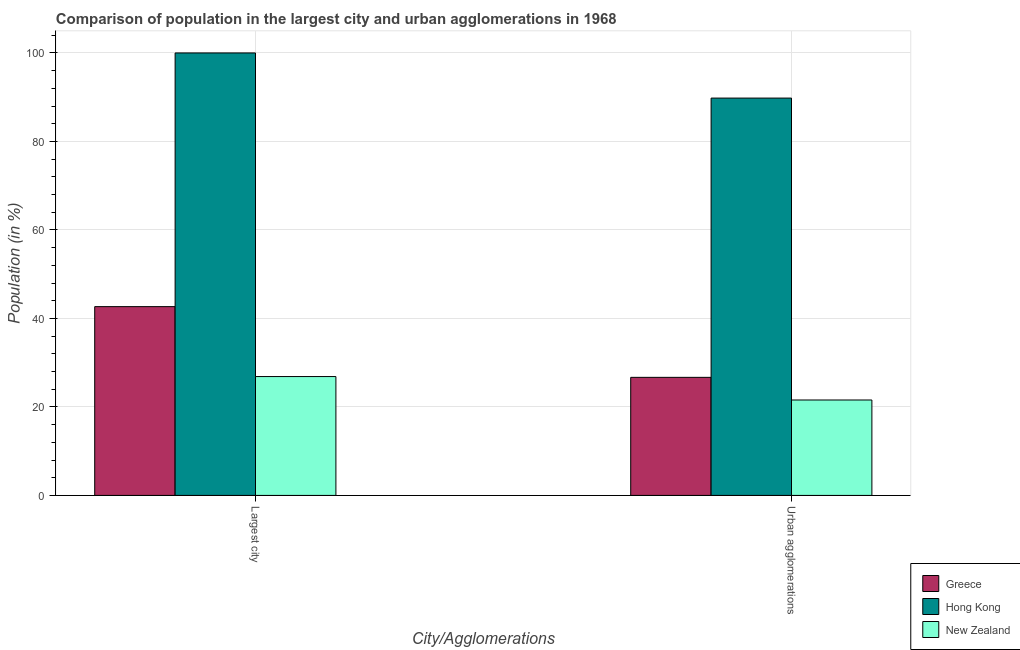How many different coloured bars are there?
Offer a very short reply. 3. How many groups of bars are there?
Your answer should be compact. 2. Are the number of bars on each tick of the X-axis equal?
Give a very brief answer. Yes. What is the label of the 1st group of bars from the left?
Make the answer very short. Largest city. What is the population in urban agglomerations in New Zealand?
Provide a short and direct response. 21.57. Across all countries, what is the minimum population in the largest city?
Your answer should be compact. 26.86. In which country was the population in urban agglomerations maximum?
Ensure brevity in your answer.  Hong Kong. In which country was the population in the largest city minimum?
Your answer should be compact. New Zealand. What is the total population in urban agglomerations in the graph?
Your response must be concise. 138.05. What is the difference between the population in urban agglomerations in Greece and that in Hong Kong?
Your answer should be compact. -63.11. What is the difference between the population in the largest city in New Zealand and the population in urban agglomerations in Greece?
Make the answer very short. 0.18. What is the average population in the largest city per country?
Provide a succinct answer. 56.51. What is the difference between the population in urban agglomerations and population in the largest city in New Zealand?
Ensure brevity in your answer.  -5.3. What is the ratio of the population in the largest city in Hong Kong to that in New Zealand?
Offer a terse response. 3.72. What does the 3rd bar from the right in Largest city represents?
Provide a short and direct response. Greece. How many bars are there?
Give a very brief answer. 6. Are all the bars in the graph horizontal?
Your response must be concise. No. What is the difference between two consecutive major ticks on the Y-axis?
Give a very brief answer. 20. Are the values on the major ticks of Y-axis written in scientific E-notation?
Give a very brief answer. No. Does the graph contain any zero values?
Offer a terse response. No. Does the graph contain grids?
Keep it short and to the point. Yes. What is the title of the graph?
Your answer should be very brief. Comparison of population in the largest city and urban agglomerations in 1968. What is the label or title of the X-axis?
Offer a terse response. City/Agglomerations. What is the Population (in %) in Greece in Largest city?
Ensure brevity in your answer.  42.67. What is the Population (in %) of New Zealand in Largest city?
Your answer should be very brief. 26.86. What is the Population (in %) in Greece in Urban agglomerations?
Offer a terse response. 26.68. What is the Population (in %) of Hong Kong in Urban agglomerations?
Your response must be concise. 89.8. What is the Population (in %) of New Zealand in Urban agglomerations?
Give a very brief answer. 21.57. Across all City/Agglomerations, what is the maximum Population (in %) of Greece?
Your response must be concise. 42.67. Across all City/Agglomerations, what is the maximum Population (in %) in New Zealand?
Your response must be concise. 26.86. Across all City/Agglomerations, what is the minimum Population (in %) in Greece?
Keep it short and to the point. 26.68. Across all City/Agglomerations, what is the minimum Population (in %) in Hong Kong?
Provide a succinct answer. 89.8. Across all City/Agglomerations, what is the minimum Population (in %) in New Zealand?
Ensure brevity in your answer.  21.57. What is the total Population (in %) of Greece in the graph?
Your answer should be compact. 69.35. What is the total Population (in %) of Hong Kong in the graph?
Your answer should be very brief. 189.8. What is the total Population (in %) in New Zealand in the graph?
Your response must be concise. 48.43. What is the difference between the Population (in %) of Greece in Largest city and that in Urban agglomerations?
Provide a succinct answer. 15.98. What is the difference between the Population (in %) in Hong Kong in Largest city and that in Urban agglomerations?
Keep it short and to the point. 10.2. What is the difference between the Population (in %) of New Zealand in Largest city and that in Urban agglomerations?
Your answer should be very brief. 5.3. What is the difference between the Population (in %) in Greece in Largest city and the Population (in %) in Hong Kong in Urban agglomerations?
Make the answer very short. -47.13. What is the difference between the Population (in %) in Greece in Largest city and the Population (in %) in New Zealand in Urban agglomerations?
Your response must be concise. 21.1. What is the difference between the Population (in %) in Hong Kong in Largest city and the Population (in %) in New Zealand in Urban agglomerations?
Make the answer very short. 78.43. What is the average Population (in %) of Greece per City/Agglomerations?
Your answer should be compact. 34.67. What is the average Population (in %) in Hong Kong per City/Agglomerations?
Ensure brevity in your answer.  94.9. What is the average Population (in %) of New Zealand per City/Agglomerations?
Offer a terse response. 24.21. What is the difference between the Population (in %) of Greece and Population (in %) of Hong Kong in Largest city?
Your answer should be compact. -57.33. What is the difference between the Population (in %) of Greece and Population (in %) of New Zealand in Largest city?
Give a very brief answer. 15.8. What is the difference between the Population (in %) in Hong Kong and Population (in %) in New Zealand in Largest city?
Your response must be concise. 73.14. What is the difference between the Population (in %) of Greece and Population (in %) of Hong Kong in Urban agglomerations?
Your answer should be very brief. -63.11. What is the difference between the Population (in %) of Greece and Population (in %) of New Zealand in Urban agglomerations?
Give a very brief answer. 5.12. What is the difference between the Population (in %) in Hong Kong and Population (in %) in New Zealand in Urban agglomerations?
Your answer should be very brief. 68.23. What is the ratio of the Population (in %) in Greece in Largest city to that in Urban agglomerations?
Your answer should be very brief. 1.6. What is the ratio of the Population (in %) in Hong Kong in Largest city to that in Urban agglomerations?
Your answer should be compact. 1.11. What is the ratio of the Population (in %) in New Zealand in Largest city to that in Urban agglomerations?
Your answer should be compact. 1.25. What is the difference between the highest and the second highest Population (in %) of Greece?
Your answer should be compact. 15.98. What is the difference between the highest and the second highest Population (in %) of Hong Kong?
Offer a terse response. 10.2. What is the difference between the highest and the second highest Population (in %) in New Zealand?
Keep it short and to the point. 5.3. What is the difference between the highest and the lowest Population (in %) in Greece?
Your answer should be very brief. 15.98. What is the difference between the highest and the lowest Population (in %) in Hong Kong?
Provide a short and direct response. 10.2. What is the difference between the highest and the lowest Population (in %) of New Zealand?
Give a very brief answer. 5.3. 